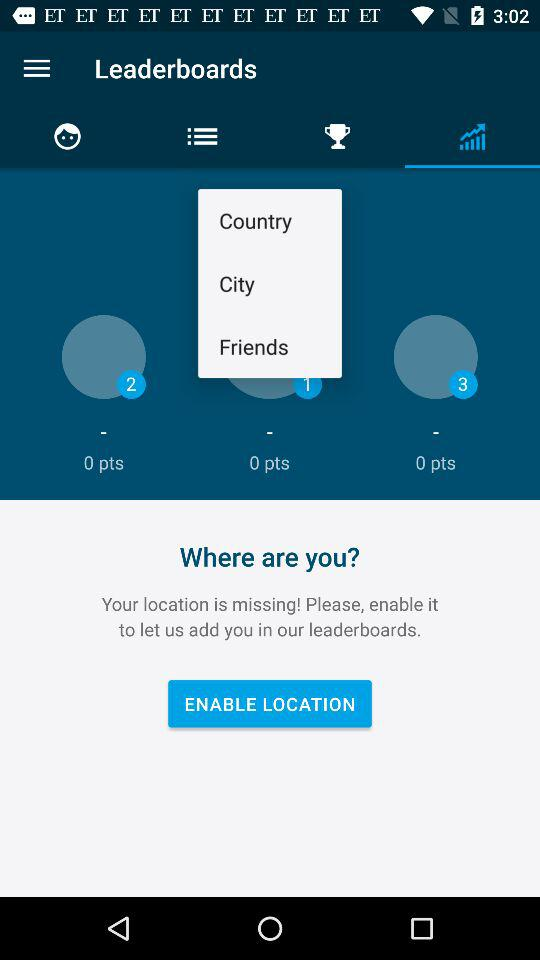What is the name of the application? The name of the application is "Leatherboards". 